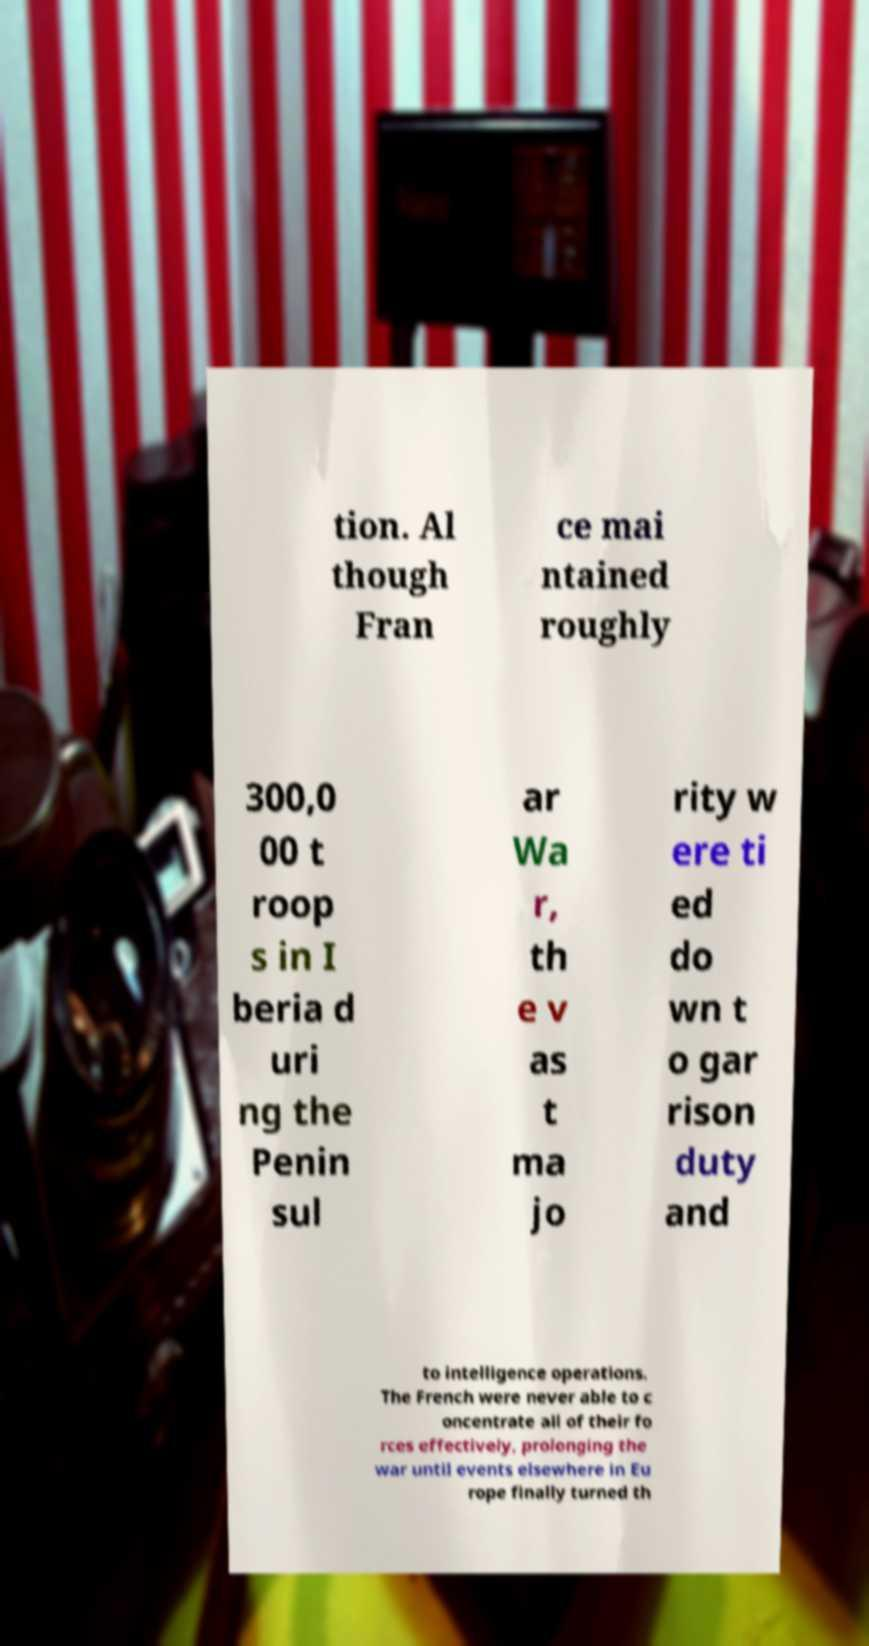Could you extract and type out the text from this image? tion. Al though Fran ce mai ntained roughly 300,0 00 t roop s in I beria d uri ng the Penin sul ar Wa r, th e v as t ma jo rity w ere ti ed do wn t o gar rison duty and to intelligence operations. The French were never able to c oncentrate all of their fo rces effectively, prolonging the war until events elsewhere in Eu rope finally turned th 